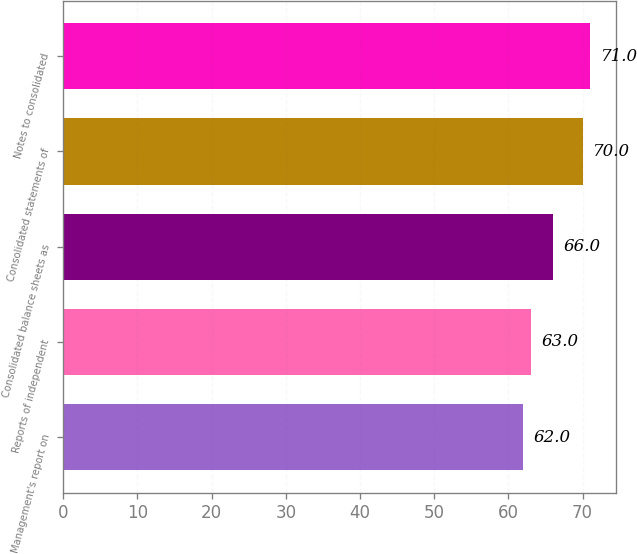Convert chart to OTSL. <chart><loc_0><loc_0><loc_500><loc_500><bar_chart><fcel>Management's report on<fcel>Reports of independent<fcel>Consolidated balance sheets as<fcel>Consolidated statements of<fcel>Notes to consolidated<nl><fcel>62<fcel>63<fcel>66<fcel>70<fcel>71<nl></chart> 